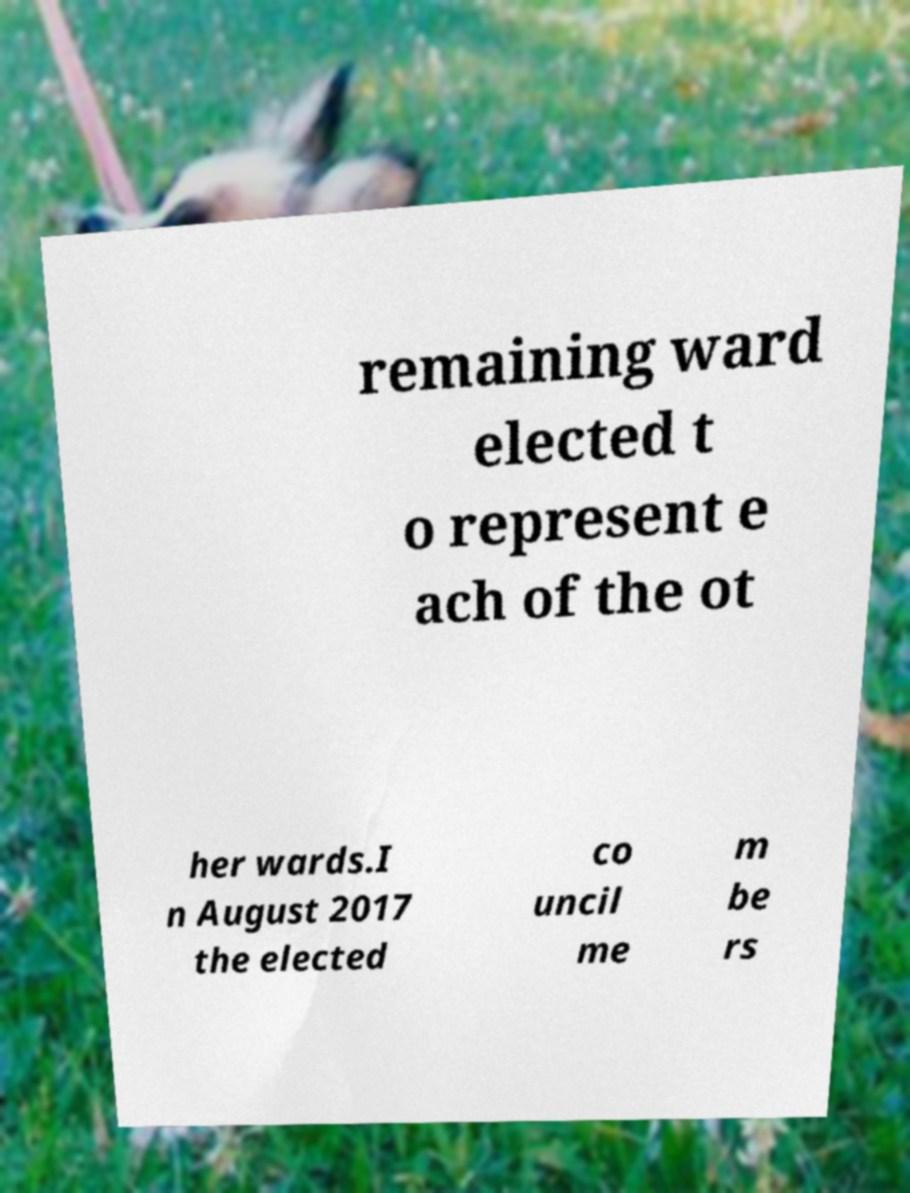What messages or text are displayed in this image? I need them in a readable, typed format. remaining ward elected t o represent e ach of the ot her wards.I n August 2017 the elected co uncil me m be rs 